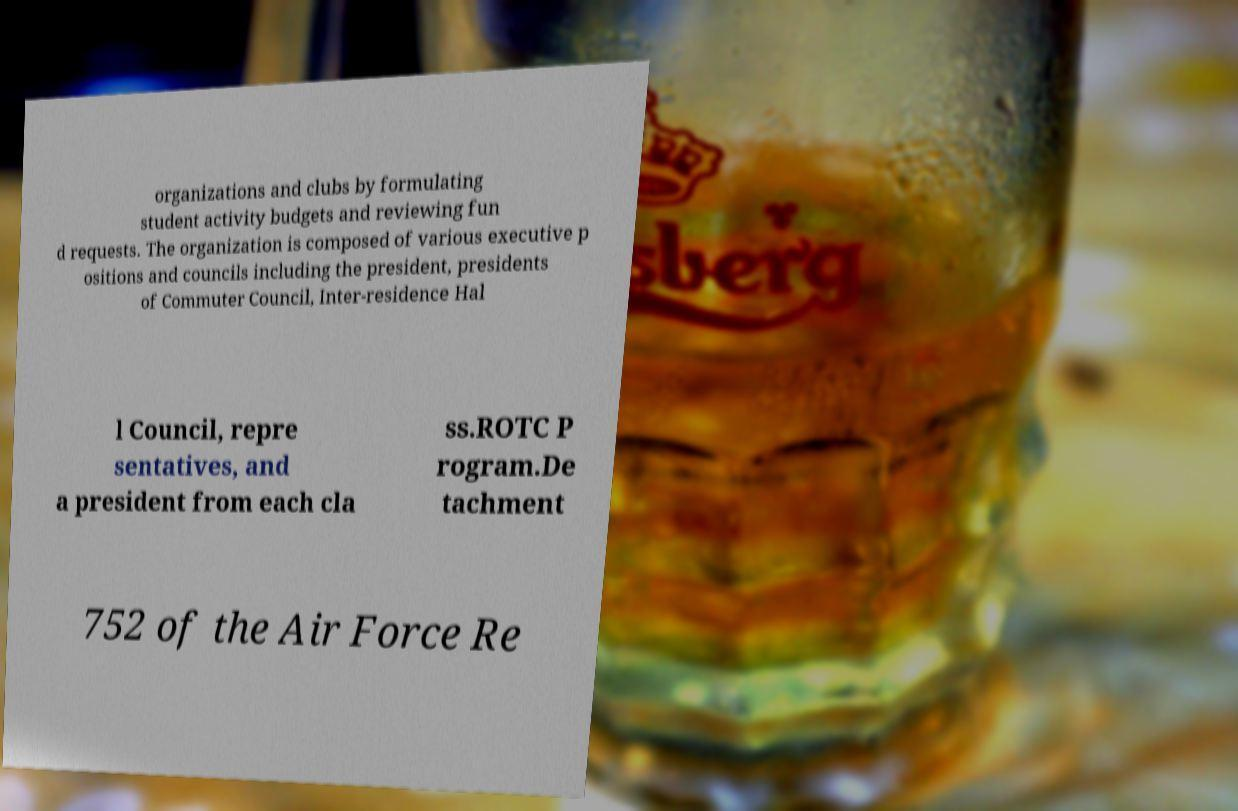Please read and relay the text visible in this image. What does it say? organizations and clubs by formulating student activity budgets and reviewing fun d requests. The organization is composed of various executive p ositions and councils including the president, presidents of Commuter Council, Inter-residence Hal l Council, repre sentatives, and a president from each cla ss.ROTC P rogram.De tachment 752 of the Air Force Re 